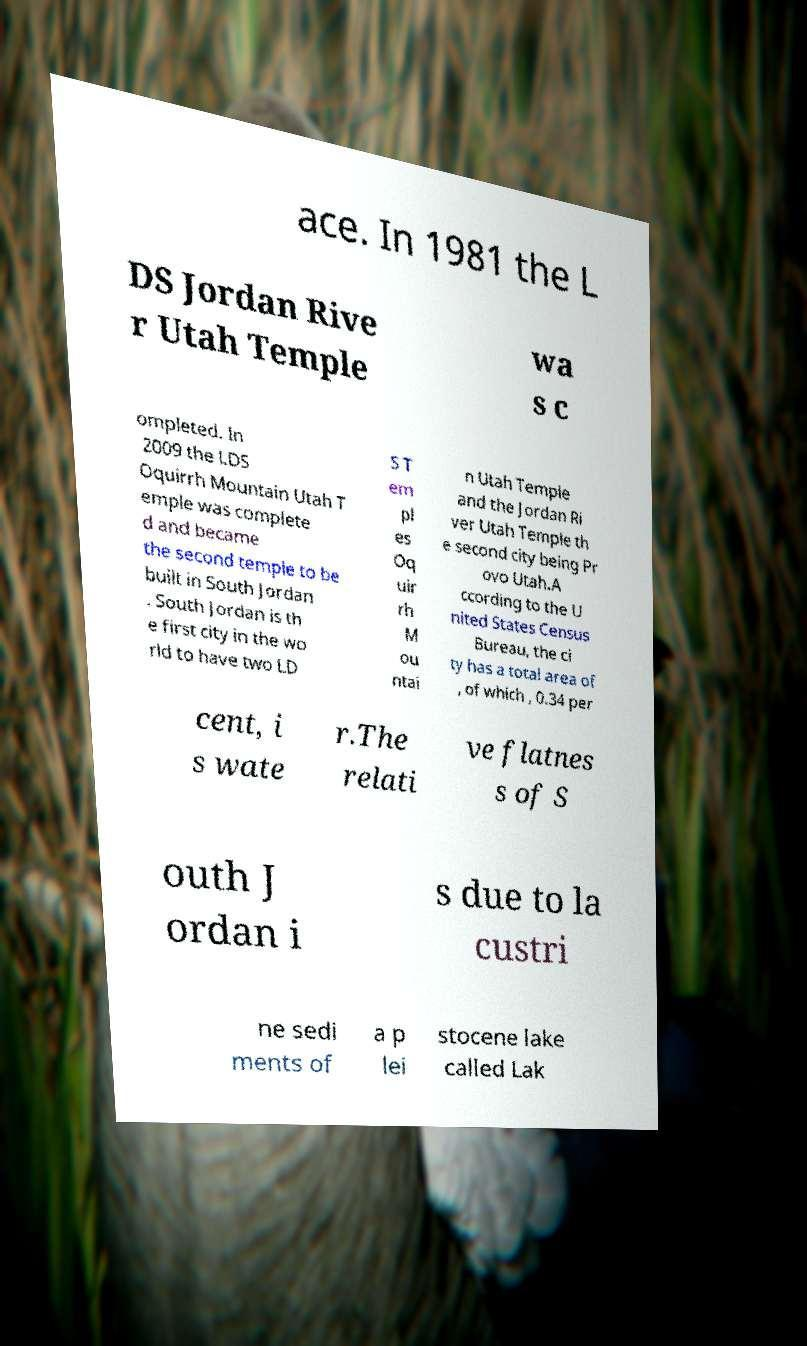There's text embedded in this image that I need extracted. Can you transcribe it verbatim? ace. In 1981 the L DS Jordan Rive r Utah Temple wa s c ompleted. In 2009 the LDS Oquirrh Mountain Utah T emple was complete d and became the second temple to be built in South Jordan . South Jordan is th e first city in the wo rld to have two LD S T em pl es Oq uir rh M ou ntai n Utah Temple and the Jordan Ri ver Utah Temple th e second city being Pr ovo Utah.A ccording to the U nited States Census Bureau, the ci ty has a total area of , of which , 0.34 per cent, i s wate r.The relati ve flatnes s of S outh J ordan i s due to la custri ne sedi ments of a p lei stocene lake called Lak 